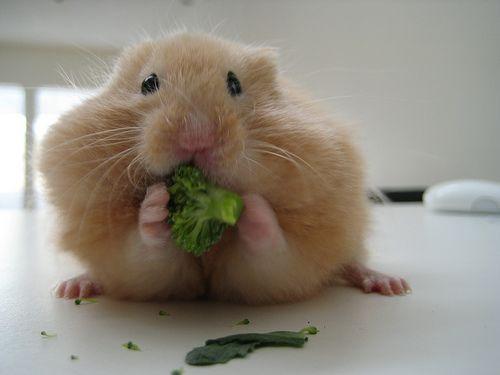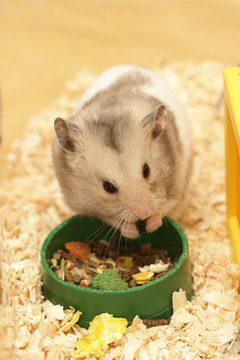The first image is the image on the left, the second image is the image on the right. For the images displayed, is the sentence "A hamster is eating broccoli on a white floor" factually correct? Answer yes or no. Yes. The first image is the image on the left, the second image is the image on the right. Evaluate the accuracy of this statement regarding the images: "A rodent is busy munching on a piece of broccoli.". Is it true? Answer yes or no. Yes. 